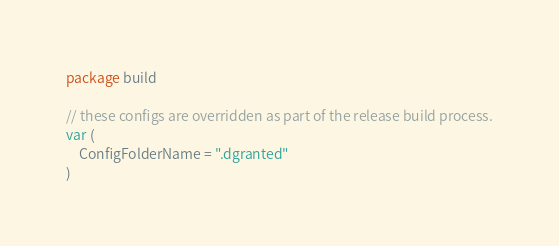Convert code to text. <code><loc_0><loc_0><loc_500><loc_500><_Go_>package build

// these configs are overridden as part of the release build process.
var (
	ConfigFolderName = ".dgranted"
)
</code> 